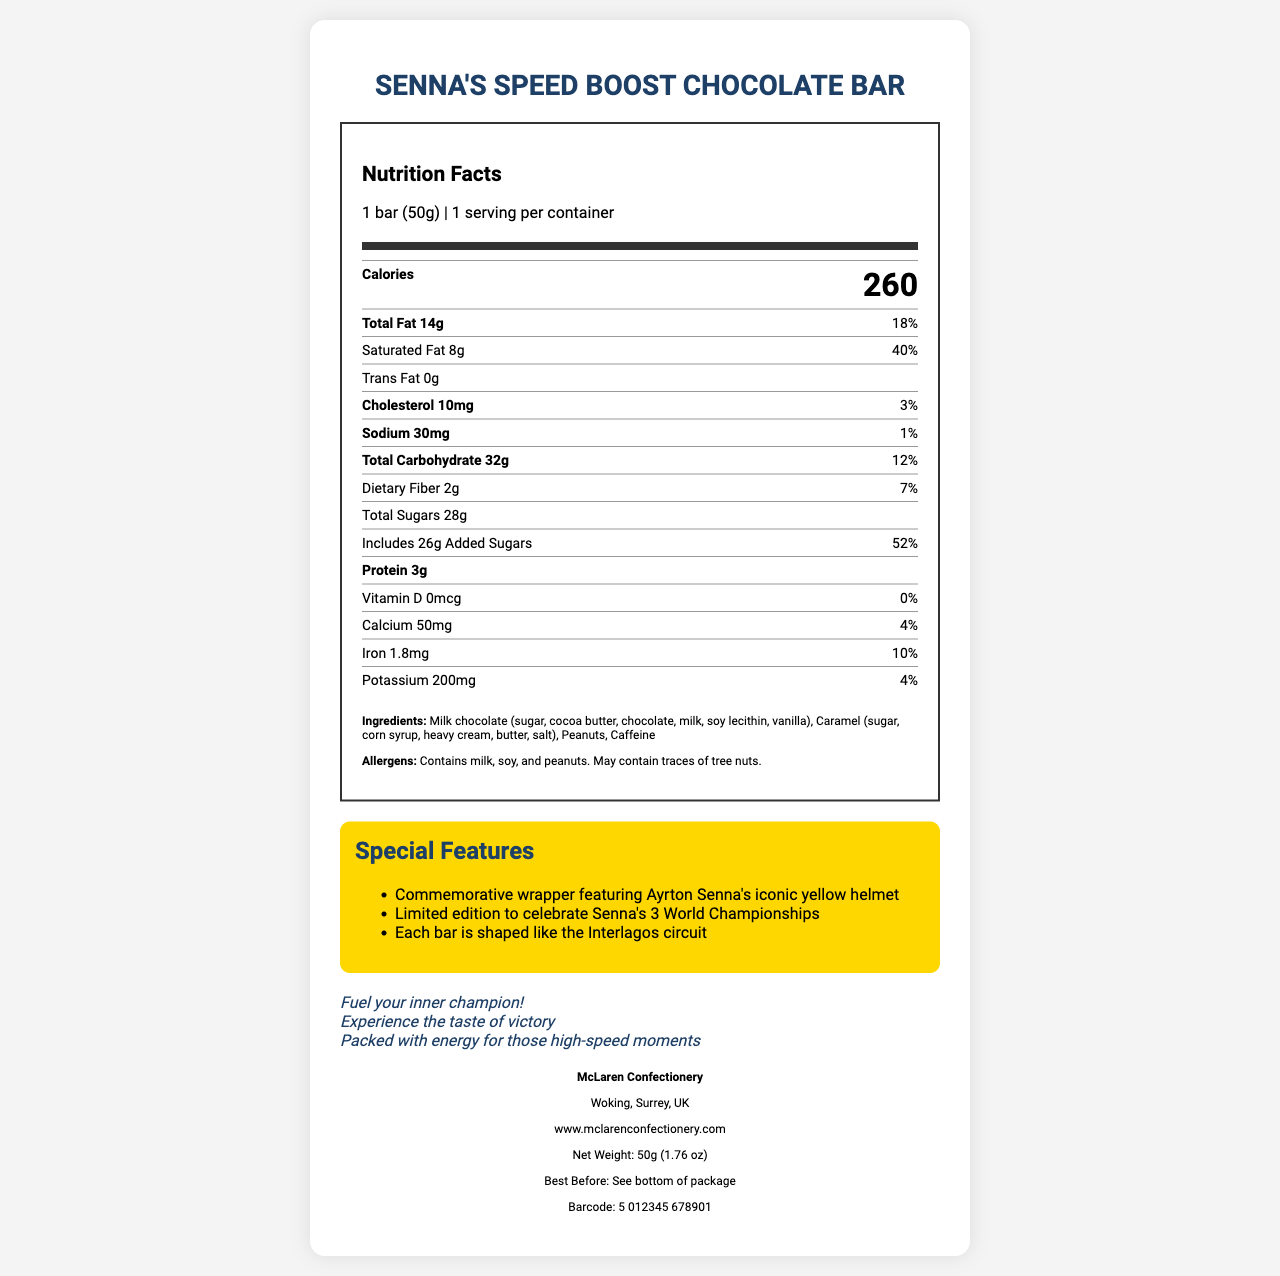what is the product name? The product name is clearly stated at the top of the document.
Answer: Senna's Speed Boost Chocolate Bar what is the serving size? The serving size is mentioned in the "Nutrition Facts" section of the document.
Answer: 1 bar (50g) how many calories are in one serving? The number of calories per serving is listed in the "Nutrition Facts" section.
Answer: 260 what is the total fat content per serving? The total fat content per serving is mentioned in the "Nutrition Facts" section.
Answer: 14g what percentage of daily value is the saturated fat? The percentage of daily value for saturated fat is listed in the "Nutrition Facts" section.
Answer: 40% what are the main ingredients of the chocolate bar? The ingredients are listed under the "Ingredients" section of the document.
Answer: Milk chocolate (sugar, cocoa butter, chocolate, milk, soy lecithin, vanilla), Caramel (sugar, corn syrup, heavy cream, butter, salt), Peanuts, Caffeine what are the allergens present in the chocolate bar? The allergen information is provided under the "Allergens" section of the document.
Answer: Contains milk, soy, and peanuts. May contain traces of tree nuts. what is the amount of added sugars in the product? The amount of added sugars is listed in the "Nutrition Facts" section.
Answer: 26g what are the special features of this chocolate bar? The special features are listed under the "Special Features" section of the document.
Answer: Commemorative wrapper featuring Ayrton Senna's iconic yellow helmet, Limited edition to celebrate Senna's 3 World Championships, Each bar is shaped like the Interlagos circuit how much iron does one bar contain? The amount of iron is mentioned in the "Nutrition Facts" section.
Answer: 1.8mg who is the manufacturer of this chocolate bar? The manufacturer's name is listed under the "Manufacturer Info" section.
Answer: McLaren Confectionery what is the net weight of the chocolate bar? The net weight is listed under the "Manufacturer Info" section.
Answer: 50g (1.76 oz) where can you see the best before date? A. On the front of the package B. On the side of the package C. On the bottom of the package D. On the back of the package The best before date location is mentioned as "See bottom of package" in the "Manufacturer Info" section.
Answer: C how much protein is in one serving of the chocolate bar? The amount of protein per serving is listed in the "Nutrition Facts" section.
Answer: 3g how much potassium does one bar contain? The amount of potassium is mentioned in the "Nutrition Facts" section.
Answer: 200mg what is the sodium content per serving? A. 10mg B. 200mg C. 30mg D. 50mg The sodium content per serving is given as 30mg in the "Nutrition Facts" section.
Answer: C does the product contain trans fat? The "Nutrition Facts" section lists trans fat as 0g, indicating no trans fat.
Answer: No what is the total carbohydrate amount per serving? The total carbohydrate amount is listed in the "Nutrition Facts" section.
Answer: 32g does the bar contain any dietary fiber? The "Nutrition Facts" section lists 2g of dietary fiber per serving.
Answer: Yes what key marketing claims are made about the product? The key marketing claims are listed under the "Marketing Claims" section of the document.
Answer: Fuel your inner champion! Experience the taste of victory. Packed with energy for those high-speed moments. describe the main idea of the document. The document includes sections on Nutrition Facts, Ingredients, Special Features, Marketing Claims, and Manufacturer Information.
Answer: The document provides detailed nutritional information, ingredients, special features, marketing claims, and manufacturer details for Senna's Speed Boost Chocolate Bar. The bar celebrates Ayrton Senna's three world championships, featuring commemorative packaging and shape. what year did Ayrton Senna win his last world championship? The document does not provide any historical information about Ayrton Senna's championship wins.
Answer: Not enough information 